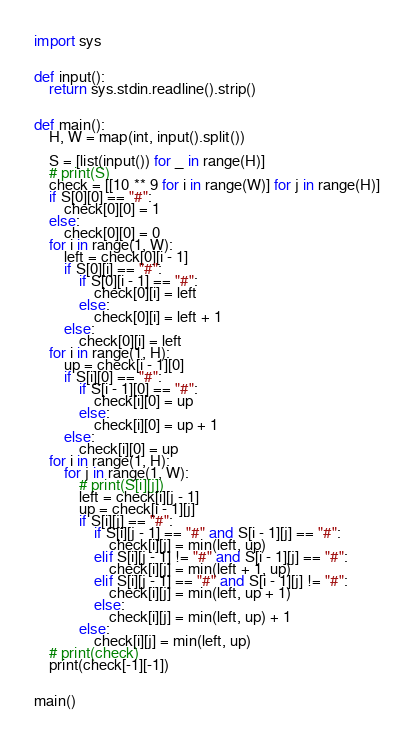<code> <loc_0><loc_0><loc_500><loc_500><_Python_>import sys


def input():
    return sys.stdin.readline().strip()


def main():
    H, W = map(int, input().split())

    S = [list(input()) for _ in range(H)]
    # print(S)
    check = [[10 ** 9 for i in range(W)] for j in range(H)]
    if S[0][0] == "#":
        check[0][0] = 1
    else:
        check[0][0] = 0
    for i in range(1, W):
        left = check[0][i - 1]
        if S[0][i] == "#":
            if S[0][i - 1] == "#":
                check[0][i] = left
            else:
                check[0][i] = left + 1
        else:
            check[0][i] = left
    for i in range(1, H):
        up = check[i - 1][0]
        if S[i][0] == "#":
            if S[i - 1][0] == "#":
                check[i][0] = up
            else:
                check[i][0] = up + 1
        else:
            check[i][0] = up
    for i in range(1, H):
        for j in range(1, W):
            # print(S[i][j])
            left = check[i][j - 1]
            up = check[i - 1][j]
            if S[i][j] == "#":
                if S[i][j - 1] == "#" and S[i - 1][j] == "#":
                    check[i][j] = min(left, up)
                elif S[i][j - 1] != "#" and S[i - 1][j] == "#":
                    check[i][j] = min(left + 1, up)
                elif S[i][j - 1] == "#" and S[i - 1][j] != "#":
                    check[i][j] = min(left, up + 1)
                else:
                    check[i][j] = min(left, up) + 1
            else:
                check[i][j] = min(left, up)
    # print(check)
    print(check[-1][-1])


main()
</code> 